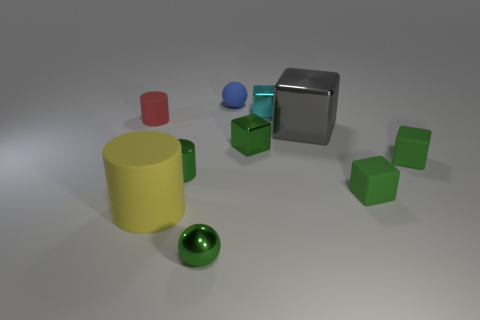Subtract all red cylinders. How many green blocks are left? 3 Subtract all yellow cubes. Subtract all cyan spheres. How many cubes are left? 5 Subtract all balls. How many objects are left? 8 Add 8 tiny purple matte spheres. How many tiny purple matte spheres exist? 8 Subtract 0 purple cylinders. How many objects are left? 10 Subtract all red things. Subtract all tiny cylinders. How many objects are left? 7 Add 9 blue rubber spheres. How many blue rubber spheres are left? 10 